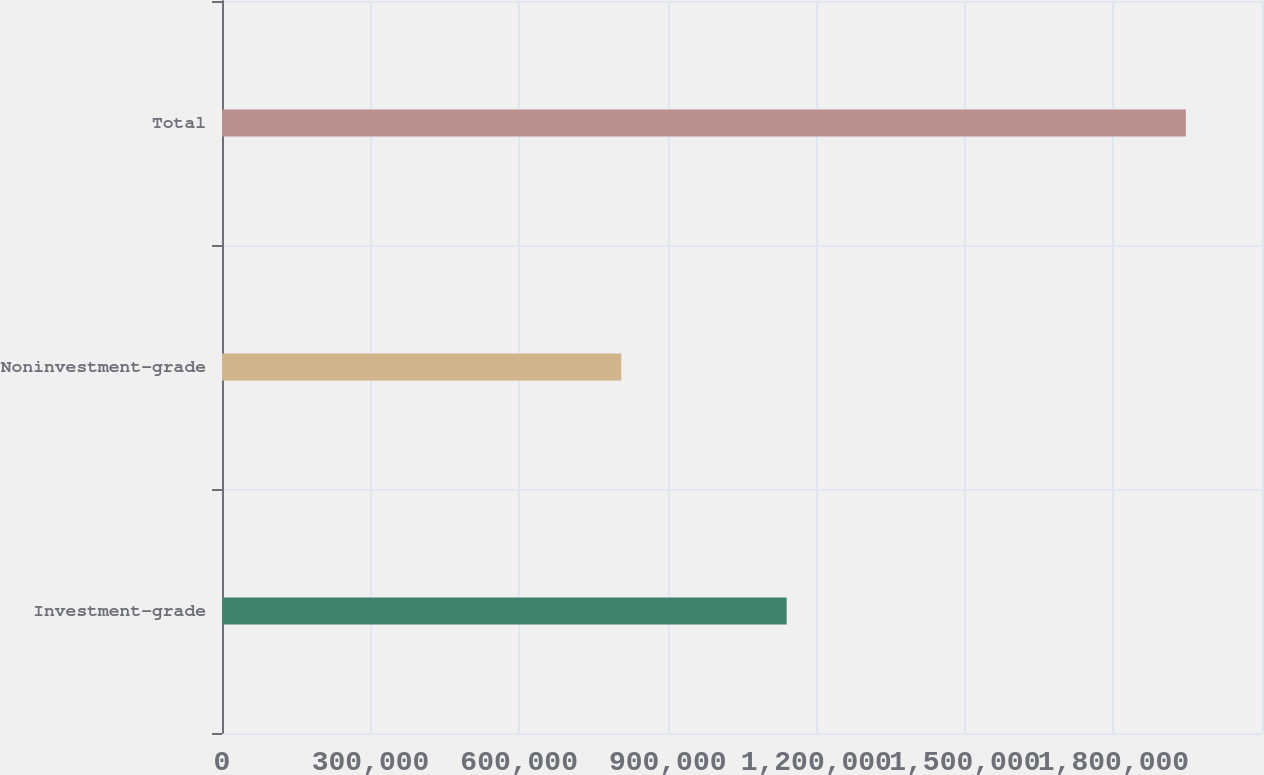Convert chart to OTSL. <chart><loc_0><loc_0><loc_500><loc_500><bar_chart><fcel>Investment-grade<fcel>Noninvestment-grade<fcel>Total<nl><fcel>1.14013e+06<fcel>806139<fcel>1.94627e+06<nl></chart> 